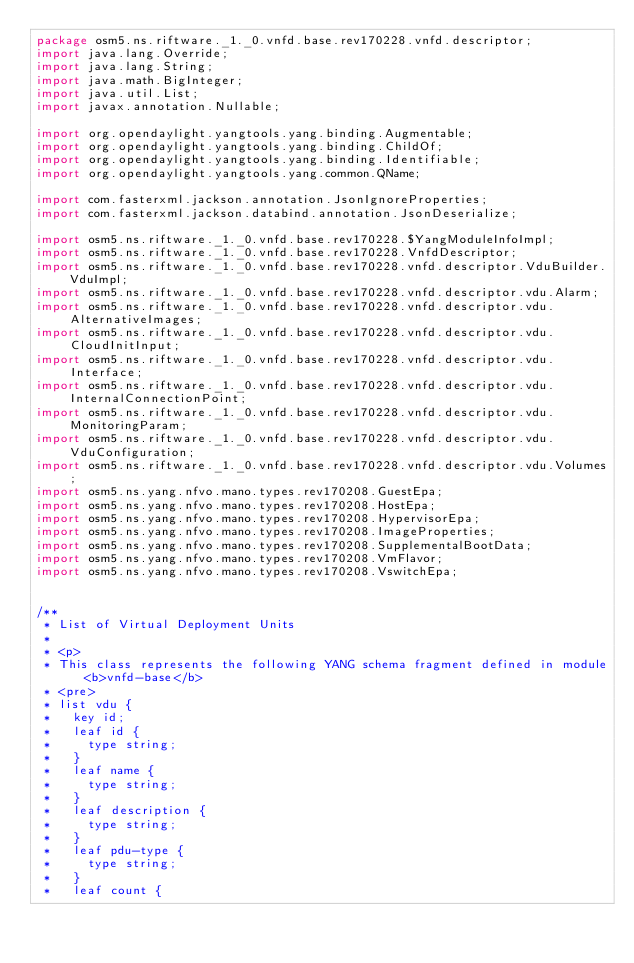Convert code to text. <code><loc_0><loc_0><loc_500><loc_500><_Java_>package osm5.ns.riftware._1._0.vnfd.base.rev170228.vnfd.descriptor;
import java.lang.Override;
import java.lang.String;
import java.math.BigInteger;
import java.util.List;
import javax.annotation.Nullable;

import org.opendaylight.yangtools.yang.binding.Augmentable;
import org.opendaylight.yangtools.yang.binding.ChildOf;
import org.opendaylight.yangtools.yang.binding.Identifiable;
import org.opendaylight.yangtools.yang.common.QName;

import com.fasterxml.jackson.annotation.JsonIgnoreProperties;
import com.fasterxml.jackson.databind.annotation.JsonDeserialize;

import osm5.ns.riftware._1._0.vnfd.base.rev170228.$YangModuleInfoImpl;
import osm5.ns.riftware._1._0.vnfd.base.rev170228.VnfdDescriptor;
import osm5.ns.riftware._1._0.vnfd.base.rev170228.vnfd.descriptor.VduBuilder.VduImpl;
import osm5.ns.riftware._1._0.vnfd.base.rev170228.vnfd.descriptor.vdu.Alarm;
import osm5.ns.riftware._1._0.vnfd.base.rev170228.vnfd.descriptor.vdu.AlternativeImages;
import osm5.ns.riftware._1._0.vnfd.base.rev170228.vnfd.descriptor.vdu.CloudInitInput;
import osm5.ns.riftware._1._0.vnfd.base.rev170228.vnfd.descriptor.vdu.Interface;
import osm5.ns.riftware._1._0.vnfd.base.rev170228.vnfd.descriptor.vdu.InternalConnectionPoint;
import osm5.ns.riftware._1._0.vnfd.base.rev170228.vnfd.descriptor.vdu.MonitoringParam;
import osm5.ns.riftware._1._0.vnfd.base.rev170228.vnfd.descriptor.vdu.VduConfiguration;
import osm5.ns.riftware._1._0.vnfd.base.rev170228.vnfd.descriptor.vdu.Volumes;
import osm5.ns.yang.nfvo.mano.types.rev170208.GuestEpa;
import osm5.ns.yang.nfvo.mano.types.rev170208.HostEpa;
import osm5.ns.yang.nfvo.mano.types.rev170208.HypervisorEpa;
import osm5.ns.yang.nfvo.mano.types.rev170208.ImageProperties;
import osm5.ns.yang.nfvo.mano.types.rev170208.SupplementalBootData;
import osm5.ns.yang.nfvo.mano.types.rev170208.VmFlavor;
import osm5.ns.yang.nfvo.mano.types.rev170208.VswitchEpa;


/**
 * List of Virtual Deployment Units
 * 
 * <p>
 * This class represents the following YANG schema fragment defined in module <b>vnfd-base</b>
 * <pre>
 * list vdu {
 *   key id;
 *   leaf id {
 *     type string;
 *   }
 *   leaf name {
 *     type string;
 *   }
 *   leaf description {
 *     type string;
 *   }
 *   leaf pdu-type {
 *     type string;
 *   }
 *   leaf count {</code> 